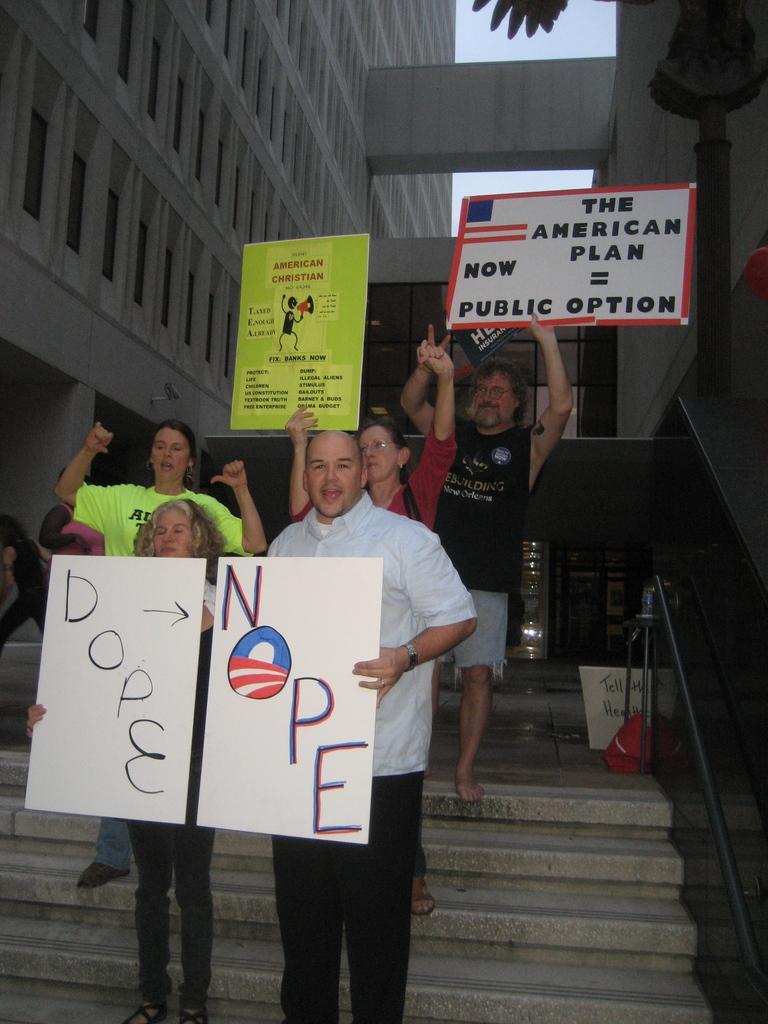Describe this image in one or two sentences. This picture describes about group of people, few people holding placards, beside to them we can find few metal rods, in the background we can see few buildings and a pole. 